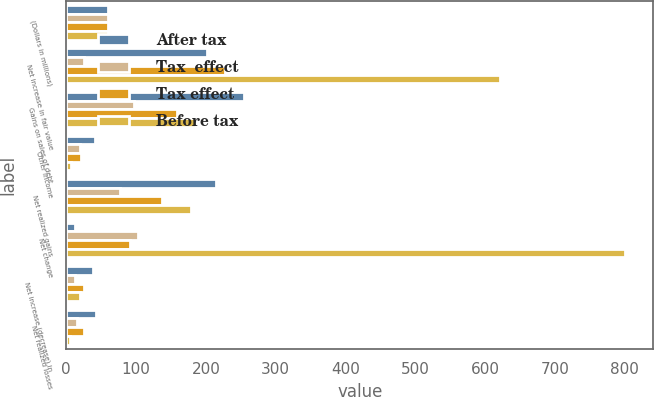Convert chart. <chart><loc_0><loc_0><loc_500><loc_500><stacked_bar_chart><ecel><fcel>(Dollars in millions)<fcel>Net increase in fair value<fcel>Gains on sales of debt<fcel>Other income<fcel>Net realized gains<fcel>Net change<fcel>Net increase (decrease) in<fcel>Net realized losses<nl><fcel>After tax<fcel>59.5<fcel>202<fcel>255<fcel>41<fcel>214<fcel>12<fcel>38<fcel>42<nl><fcel>Tax  effect<fcel>59.5<fcel>26<fcel>97<fcel>20<fcel>77<fcel>103<fcel>12<fcel>16<nl><fcel>Tax effect<fcel>59.5<fcel>228<fcel>158<fcel>21<fcel>137<fcel>91<fcel>26<fcel>26<nl><fcel>Before tax<fcel>59.5<fcel>622<fcel>186<fcel>7<fcel>179<fcel>801<fcel>19<fcel>6<nl></chart> 